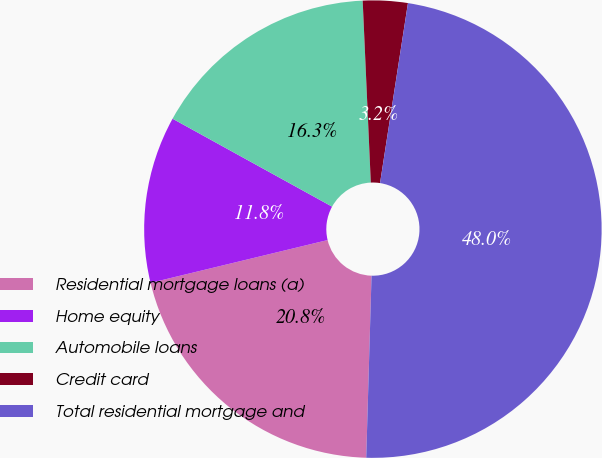Convert chart. <chart><loc_0><loc_0><loc_500><loc_500><pie_chart><fcel>Residential mortgage loans (a)<fcel>Home equity<fcel>Automobile loans<fcel>Credit card<fcel>Total residential mortgage and<nl><fcel>20.76%<fcel>11.79%<fcel>16.27%<fcel>3.16%<fcel>48.01%<nl></chart> 